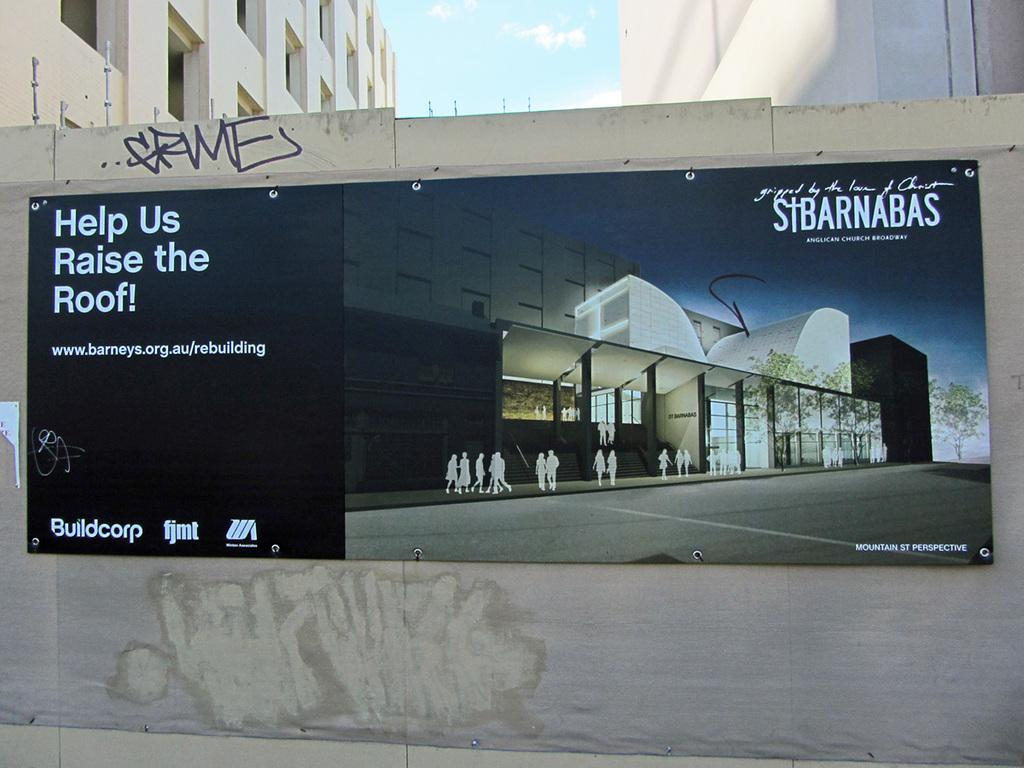<image>
Present a compact description of the photo's key features. An ad on the side of the building that has Buildcorp on it 